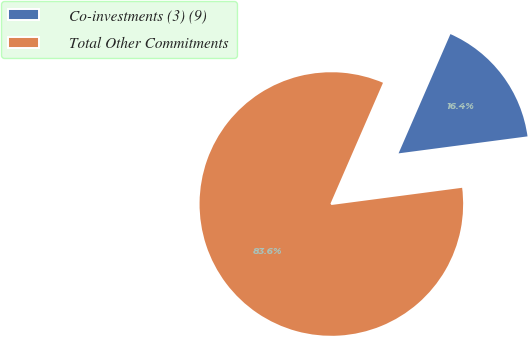<chart> <loc_0><loc_0><loc_500><loc_500><pie_chart><fcel>Co-investments (3) (9)<fcel>Total Other Commitments<nl><fcel>16.39%<fcel>83.61%<nl></chart> 